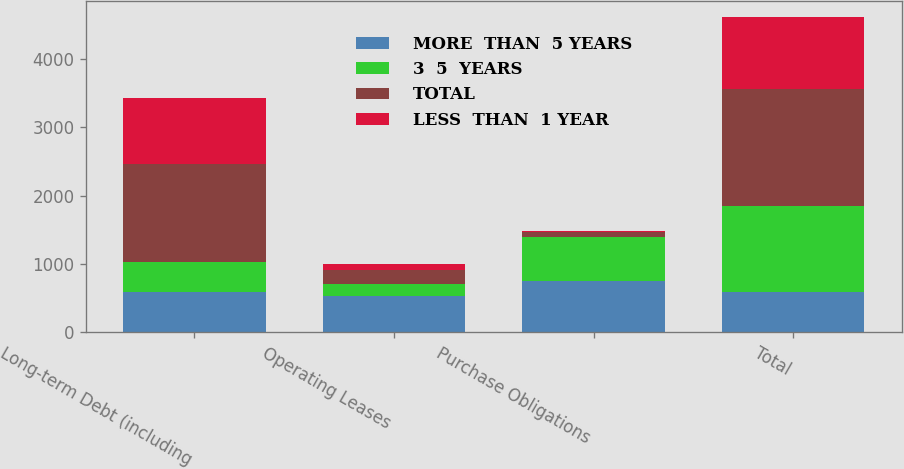Convert chart. <chart><loc_0><loc_0><loc_500><loc_500><stacked_bar_chart><ecel><fcel>Long-term Debt (including<fcel>Operating Leases<fcel>Purchase Obligations<fcel>Total<nl><fcel>MORE  THAN  5 YEARS<fcel>595.5<fcel>536<fcel>746<fcel>595.5<nl><fcel>3  5  YEARS<fcel>428<fcel>171<fcel>655<fcel>1254<nl><fcel>TOTAL<fcel>1434<fcel>206<fcel>71<fcel>1711<nl><fcel>LESS  THAN  1 YEAR<fcel>966<fcel>80<fcel>14<fcel>1060<nl></chart> 